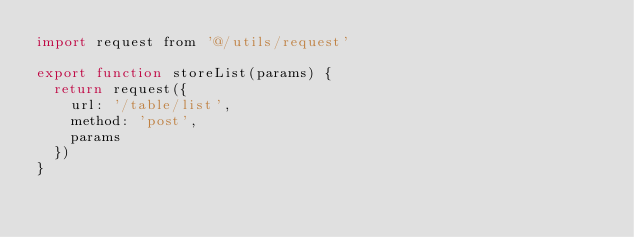Convert code to text. <code><loc_0><loc_0><loc_500><loc_500><_JavaScript_>import request from '@/utils/request'

export function storeList(params) {
  return request({
    url: '/table/list',
    method: 'post',
    params
  })
}
</code> 